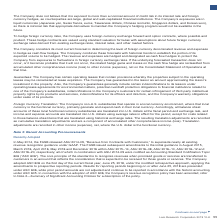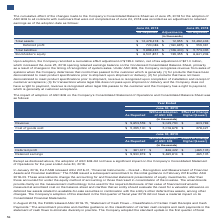According to Lam Research Corporation's financial document, What is the stockholder's equity as reported in June 24, 2018? According to the financial document, $6,501,851 (in thousands). The relevant text states: "Stockholder’s equity $ 6,501,851 $ 139,355 $ 6,641,206..." Also, What is the total liabilities as reported in June 24, 2018? According to the financial document, $5,899,435 (in thousands). The relevant text states: "Total liabilities $ 5,899,435 $ (126,400) $ 5,773,035..." Also, What is the deferred profit as reported in June 24, 2018? According to the financial document, $720,086 (in thousands). The relevant text states: "Deferred profit $ 720,086 $ (160,695) $ 559,391..." Also, can you calculate: What is the percentage change in the total assets after the adjustment? To answer this question, I need to perform calculations using the financial data. The calculation is: (12,492,433-12,479,478)/12,479,478, which equals 0.1 (percentage). This is based on the information: "Total assets $ 12,479,478 $ 12,955 $ 12,492,433 Total assets $ 12,479,478 $ 12,955 $ 12,492,433..." The key data points involved are: 12,479,478, 12,492,433. Also, can you calculate: What is the percentage change in the deferred profit after the adjustment? To answer this question, I need to perform calculations using the financial data. The calculation is: (559,391-720,086)/720,086, which equals -22.32 (percentage). This is based on the information: "Deferred profit $ 720,086 $ (160,695) $ 559,391 Deferred profit $ 720,086 $ (160,695) $ 559,391..." The key data points involved are: 559,391, 720,086. Also, can you calculate: What is the percentage change in the total liabilities after the adjustment? To answer this question, I need to perform calculations using the financial data. The calculation is: (5,773,035-5,899,435)/5,899,435, which equals -2.14 (percentage). This is based on the information: "Total liabilities $ 5,899,435 $ (126,400) $ 5,773,035 Total liabilities $ 5,899,435 $ (126,400) $ 5,773,035..." The key data points involved are: 5,773,035, 5,899,435. 